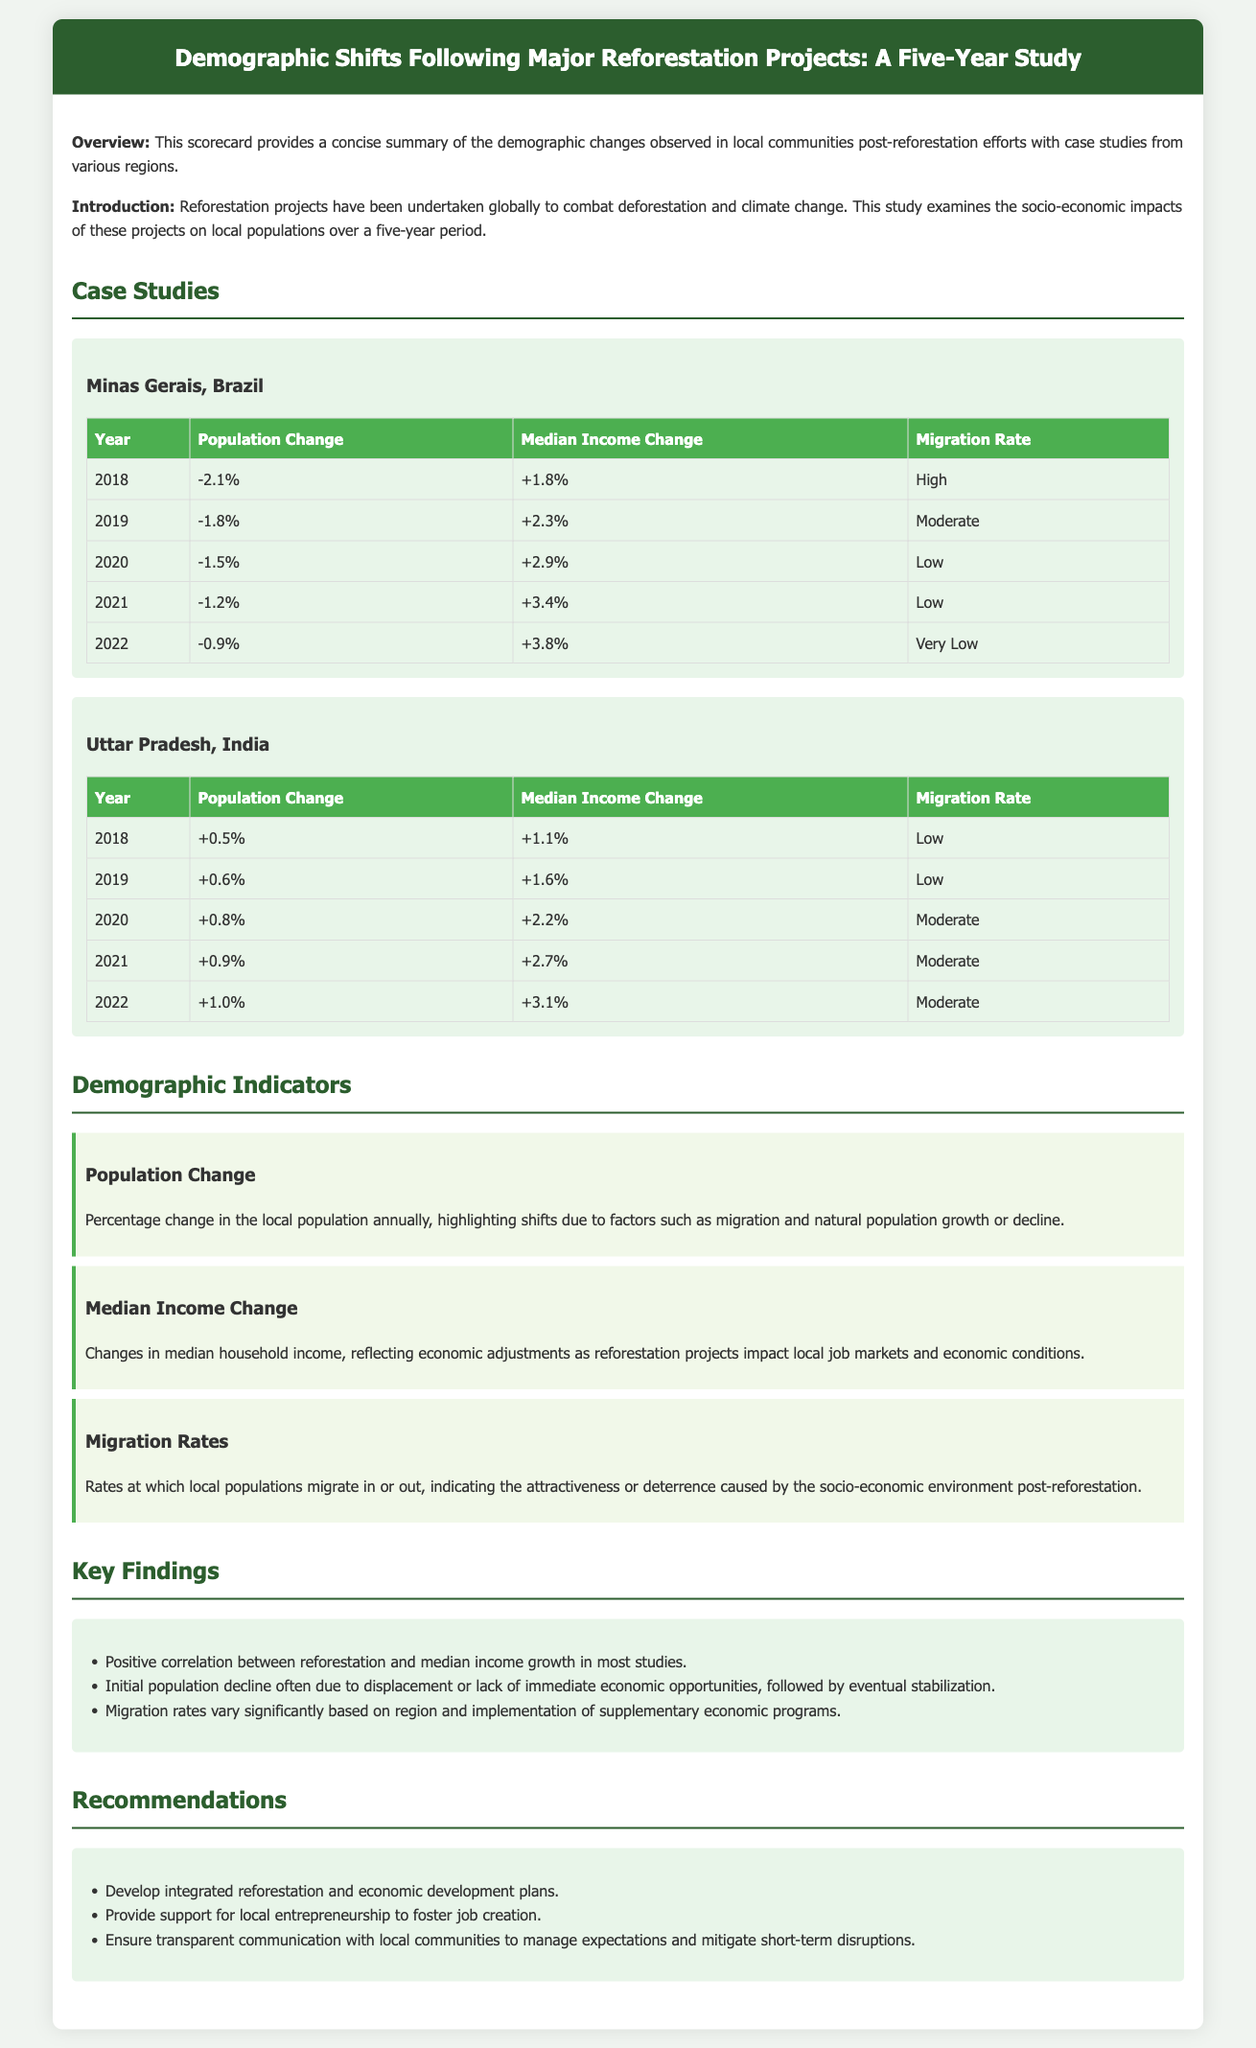What was the population change in Minas Gerais in 2020? The population change for Minas Gerais in 2020 is retrieved from the table which states a decline of 1.5%.
Answer: -1.5% What was the median income change in Uttar Pradesh, India in 2022? The median income change for Uttar Pradesh in 2022 is found in the respective table, indicating an increase of 3.1%.
Answer: +3.1% Which region experienced a high migration rate in 2018? The migration rate for Minas Gerais in 2018 is classified as "High" according to the data provided.
Answer: High What is the trend in population change in Uttar Pradesh over the five years? An analysis of the population change data shows gradual increases each year, leading to a positive trend.
Answer: Positive trend What recommendation is made for job creation? The recommendations section suggests providing support for local entrepreneurship as a strategy for fostering job creation.
Answer: Support for local entrepreneurship What was the median income change from 2018 to 2019 in Minas Gerais? The change in median income from 2018 to 2019 can be found in the table, showing an increase of 2.3% from a previous increase of 1.8%.
Answer: +2.3% What does the population change indicator express according to the document? The population change indicator explains the percentage change in local population annually influenced by various factors, including migration.
Answer: Percentage change in local population annually What key finding mentions the relationship between reforestation and income? A key finding indicates a positive correlation between reforestation and median income growth in most studies, showcasing an economic impact.
Answer: Positive correlation What year saw the least population decline in Minas Gerais? By reviewing the population changes, the year 2022 shows the least decline of only 0.9%.
Answer: 2022 